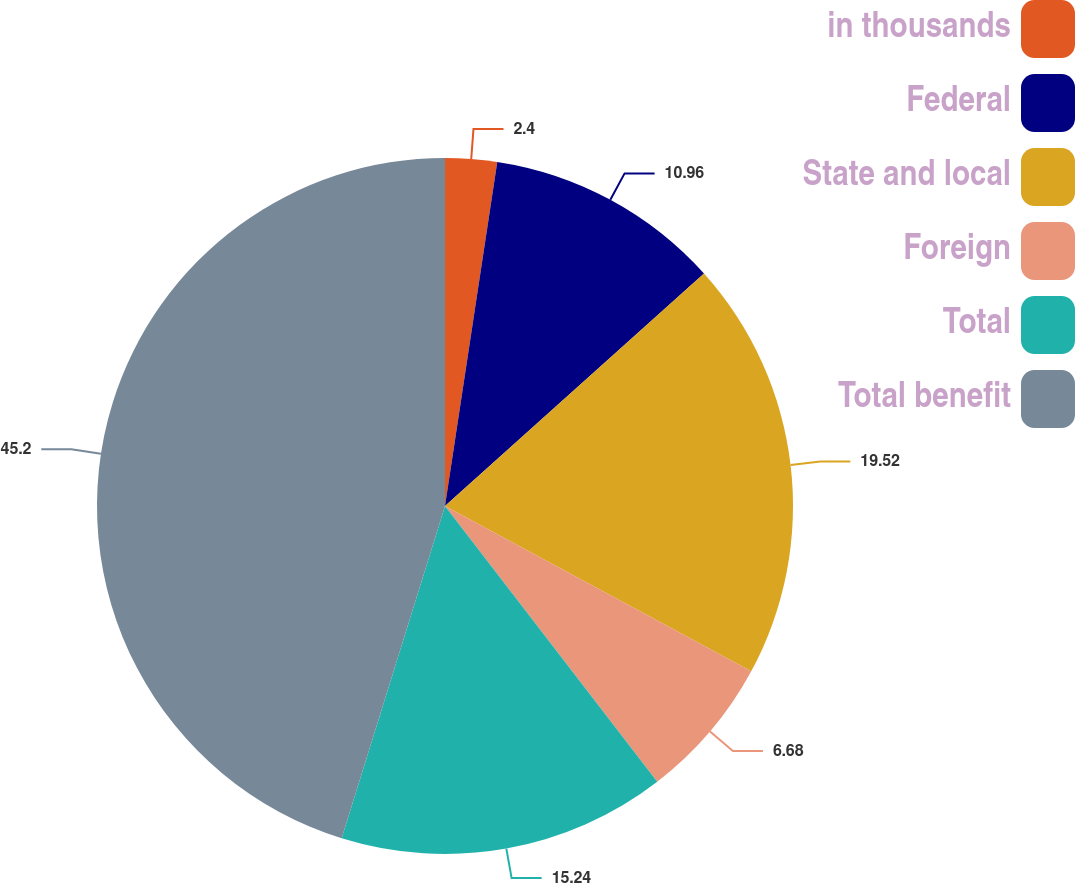Convert chart to OTSL. <chart><loc_0><loc_0><loc_500><loc_500><pie_chart><fcel>in thousands<fcel>Federal<fcel>State and local<fcel>Foreign<fcel>Total<fcel>Total benefit<nl><fcel>2.4%<fcel>10.96%<fcel>19.52%<fcel>6.68%<fcel>15.24%<fcel>45.2%<nl></chart> 